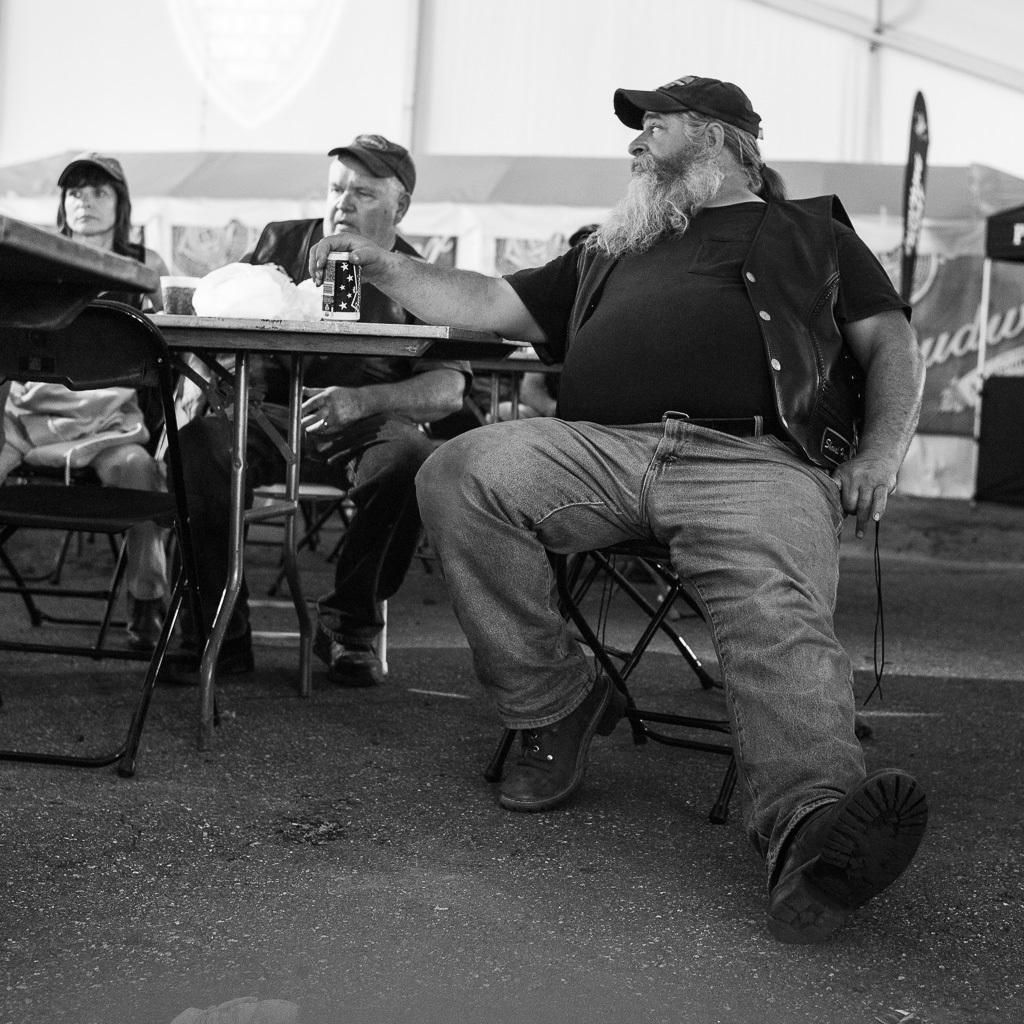How would you summarize this image in a sentence or two? In this picture we can see we can three persons sitting on the chairs. This is the table and there is a tin. This is the road. 